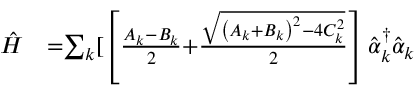Convert formula to latex. <formula><loc_0><loc_0><loc_500><loc_500>\begin{array} { l l } { \hat { H } } & { { = } { \sum } _ { k } [ \left [ \frac { A _ { k } { - } B _ { k } } { 2 } { + } \frac { \sqrt { \left ( A _ { k } { + } B _ { k } \right ) ^ { 2 } { - } { 4 } C _ { k } ^ { 2 } } } { 2 } \right ] \hat { \alpha } _ { k } ^ { \dagger } \hat { \alpha } _ { k } } \end{array}</formula> 